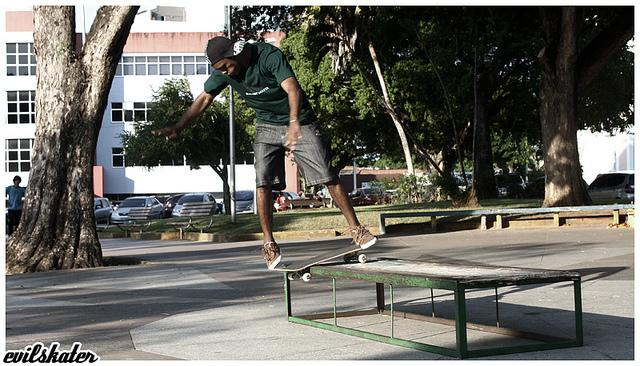What wheeled object is the man riding on to perform the stunt? skateboard 